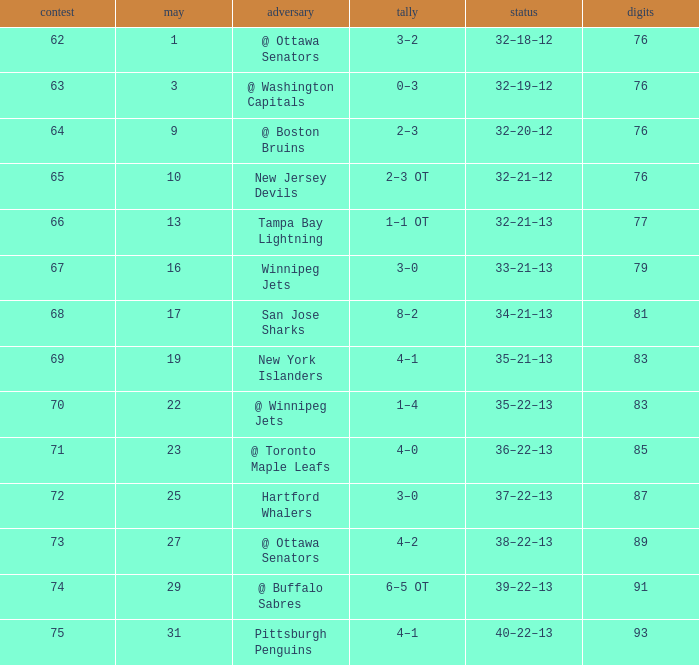Which Game is the lowest one that has a Score of 2–3 ot, and Points larger than 76? None. 